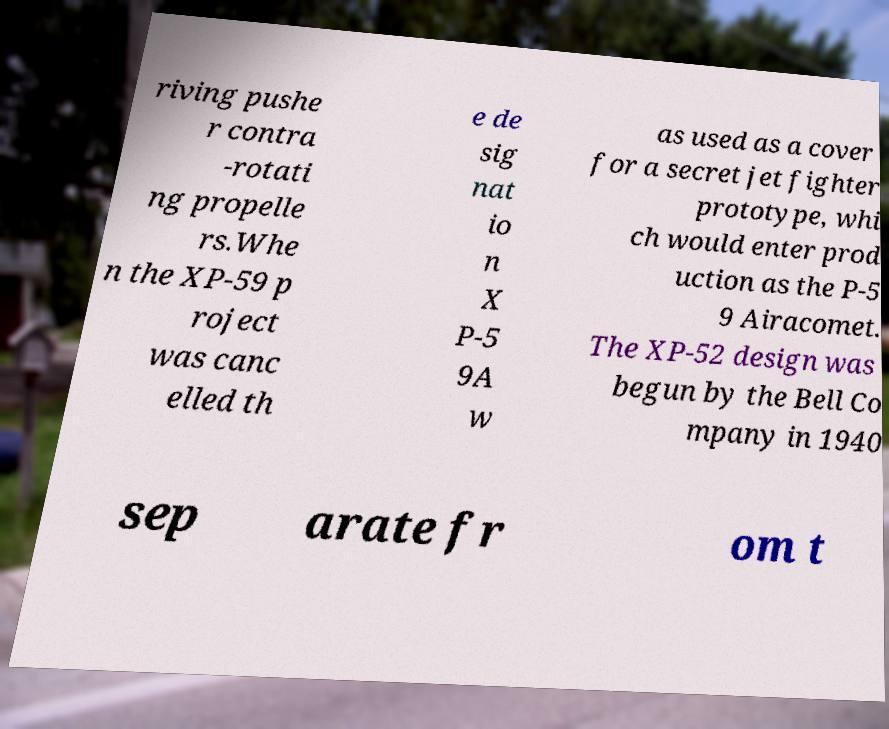Please read and relay the text visible in this image. What does it say? riving pushe r contra -rotati ng propelle rs.Whe n the XP-59 p roject was canc elled th e de sig nat io n X P-5 9A w as used as a cover for a secret jet fighter prototype, whi ch would enter prod uction as the P-5 9 Airacomet. The XP-52 design was begun by the Bell Co mpany in 1940 sep arate fr om t 